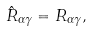Convert formula to latex. <formula><loc_0><loc_0><loc_500><loc_500>\hat { R } _ { \alpha \gamma } = R _ { \alpha \gamma } ,</formula> 